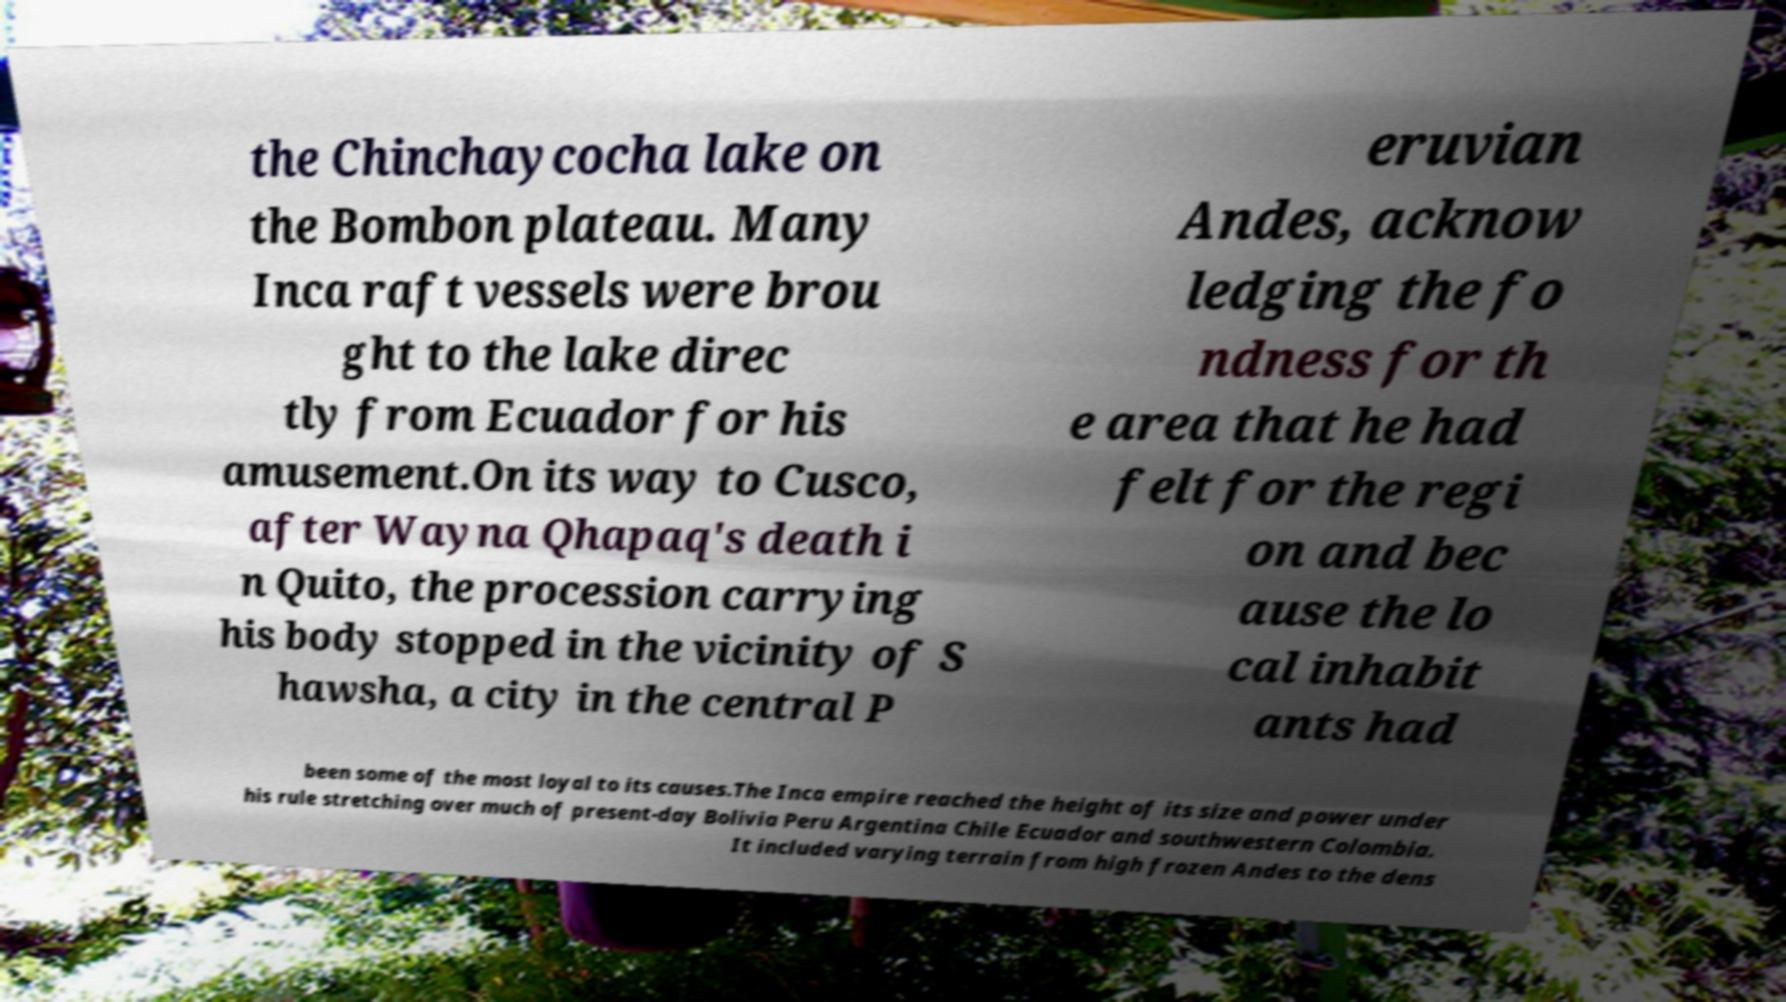I need the written content from this picture converted into text. Can you do that? the Chinchaycocha lake on the Bombon plateau. Many Inca raft vessels were brou ght to the lake direc tly from Ecuador for his amusement.On its way to Cusco, after Wayna Qhapaq's death i n Quito, the procession carrying his body stopped in the vicinity of S hawsha, a city in the central P eruvian Andes, acknow ledging the fo ndness for th e area that he had felt for the regi on and bec ause the lo cal inhabit ants had been some of the most loyal to its causes.The Inca empire reached the height of its size and power under his rule stretching over much of present-day Bolivia Peru Argentina Chile Ecuador and southwestern Colombia. It included varying terrain from high frozen Andes to the dens 